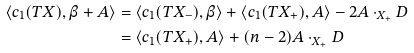Convert formula to latex. <formula><loc_0><loc_0><loc_500><loc_500>\langle c _ { 1 } ( T X ) , \beta + A \rangle & = \langle c _ { 1 } ( T X _ { - } ) , \beta \rangle + \langle c _ { 1 } ( T X _ { + } ) , A \rangle - 2 A \cdot _ { X _ { + } } D \\ & = \langle c _ { 1 } ( T X _ { + } ) , A \rangle + ( n - 2 ) A \cdot _ { X _ { + } } D</formula> 